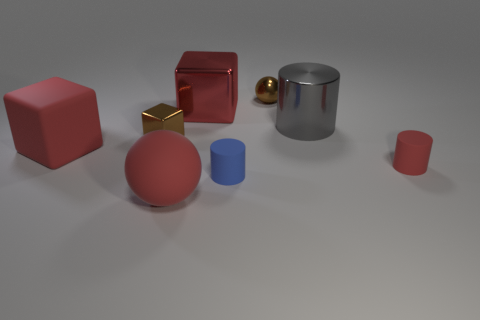What color is the small object behind the big red object behind the tiny brown shiny cube? I cannot provide details about the small object's color without visual confirmation, as the image may contain multiple objects with varying colors and arrangements. 